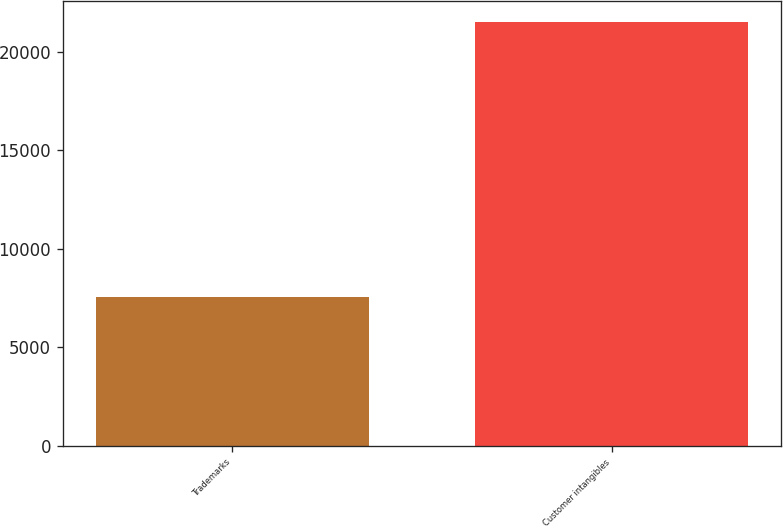Convert chart. <chart><loc_0><loc_0><loc_500><loc_500><bar_chart><fcel>Trademarks<fcel>Customer intangibles<nl><fcel>7581<fcel>21513<nl></chart> 